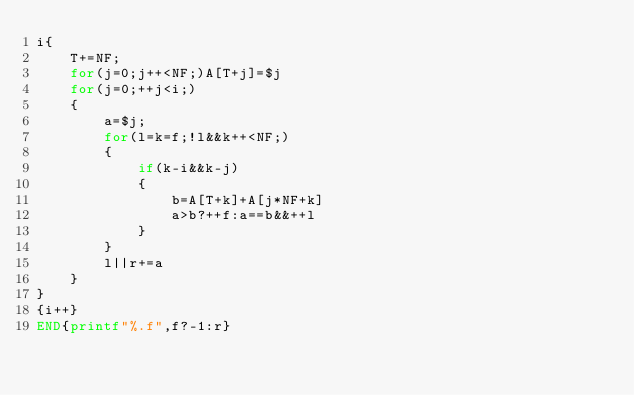<code> <loc_0><loc_0><loc_500><loc_500><_Awk_>i{
	T+=NF;
	for(j=0;j++<NF;)A[T+j]=$j
	for(j=0;++j<i;)
	{
		a=$j;
		for(l=k=f;!l&&k++<NF;)
		{
			if(k-i&&k-j)
			{
				b=A[T+k]+A[j*NF+k]
				a>b?++f:a==b&&++l
			}
		}
		l||r+=a
	}
}
{i++}
END{printf"%.f",f?-1:r}</code> 